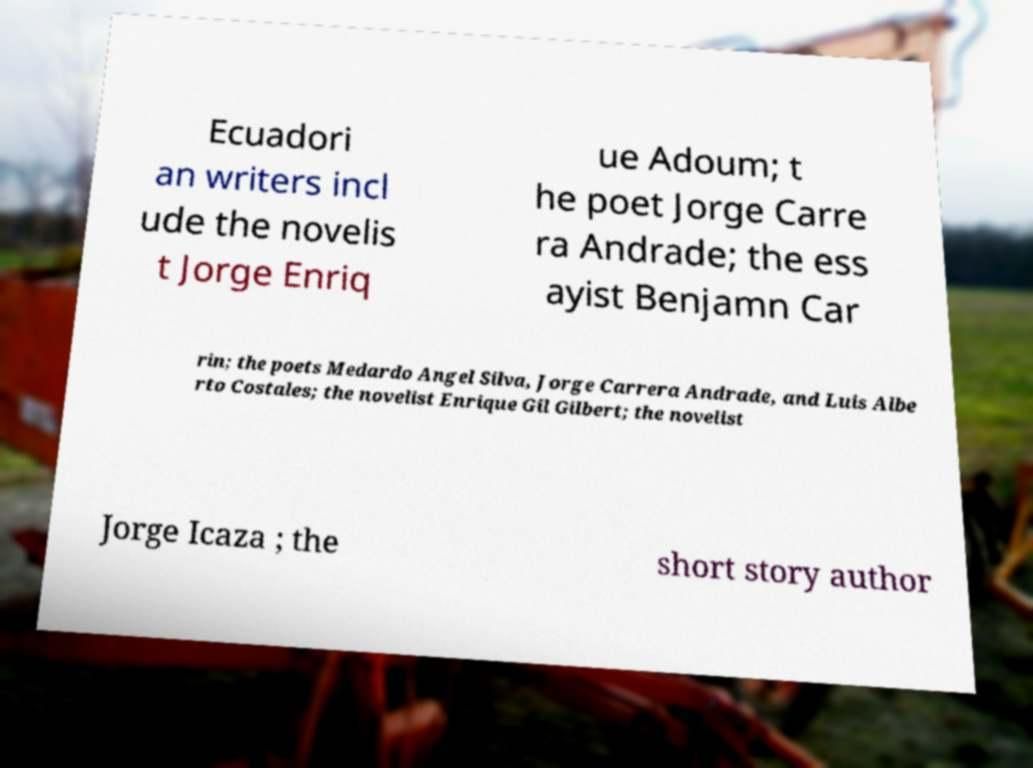For documentation purposes, I need the text within this image transcribed. Could you provide that? Ecuadori an writers incl ude the novelis t Jorge Enriq ue Adoum; t he poet Jorge Carre ra Andrade; the ess ayist Benjamn Car rin; the poets Medardo Angel Silva, Jorge Carrera Andrade, and Luis Albe rto Costales; the novelist Enrique Gil Gilbert; the novelist Jorge Icaza ; the short story author 